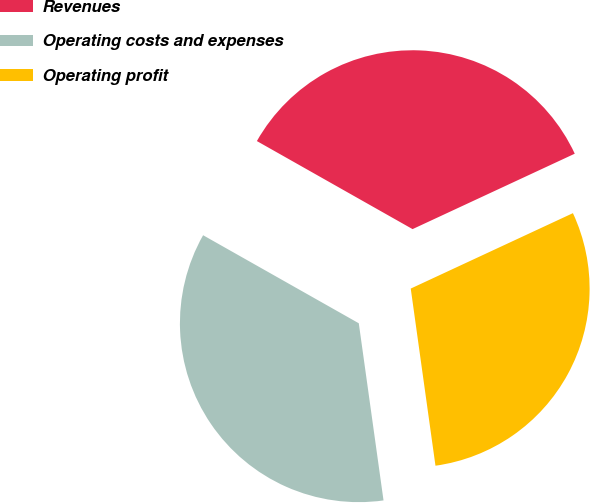<chart> <loc_0><loc_0><loc_500><loc_500><pie_chart><fcel>Revenues<fcel>Operating costs and expenses<fcel>Operating profit<nl><fcel>34.88%<fcel>35.4%<fcel>29.72%<nl></chart> 